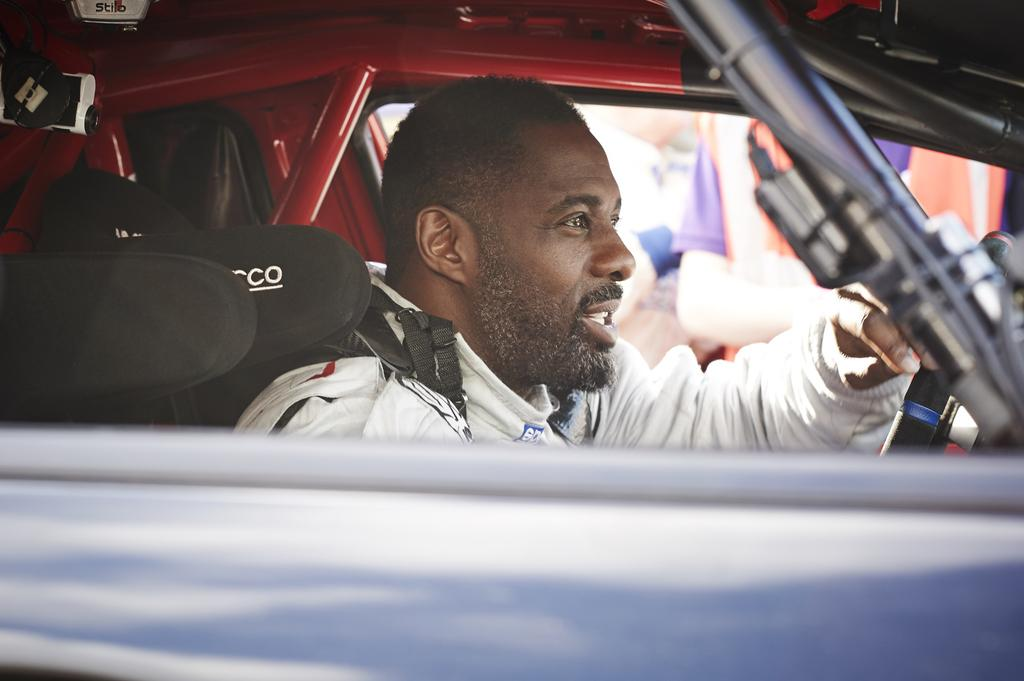Who is present in the image? There is a person in the image. What is the person wearing? The person is wearing a white jacket. Where is the person located in the image? The person is sitting in a car. What is the person doing in the car? The person is holding the steering wheel. What type of fiction is the person reading in the image? There is no book or any form of reading material present in the image, so it cannot be determined if the person is reading fiction or any other type of content. 